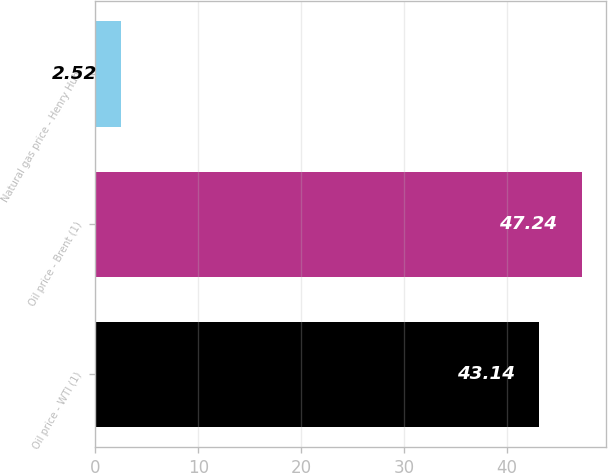Convert chart to OTSL. <chart><loc_0><loc_0><loc_500><loc_500><bar_chart><fcel>Oil price - WTI (1)<fcel>Oil price - Brent (1)<fcel>Natural gas price - Henry Hub<nl><fcel>43.14<fcel>47.24<fcel>2.52<nl></chart> 